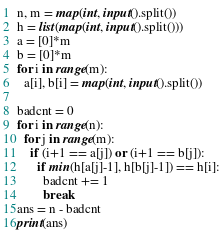Convert code to text. <code><loc_0><loc_0><loc_500><loc_500><_Python_>n, m = map(int, input().split())
h = list(map(int, input().split())) 
a = [0]*m
b = [0]*m
for i in range(m):
  a[i], b[i] = map(int, input().split())

badcnt = 0
for i in range(n):
  for j in range(m):
    if (i+1 == a[j]) or (i+1 == b[j]):
      if min(h[a[j]-1], h[b[j]-1]) == h[i]:
        badcnt += 1
        break
ans = n - badcnt        
print(ans)</code> 